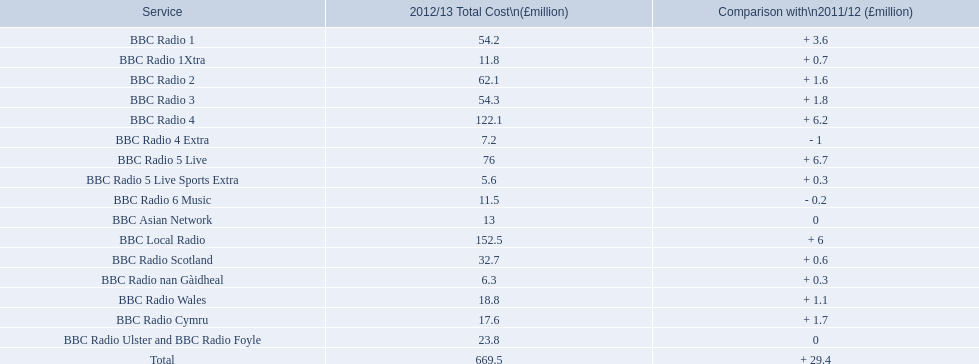In 2012/13, what was the maximum cost incurred to operate a station? 152.5. During this time, which station had a running expense of £152.5 million? BBC Local Radio. 